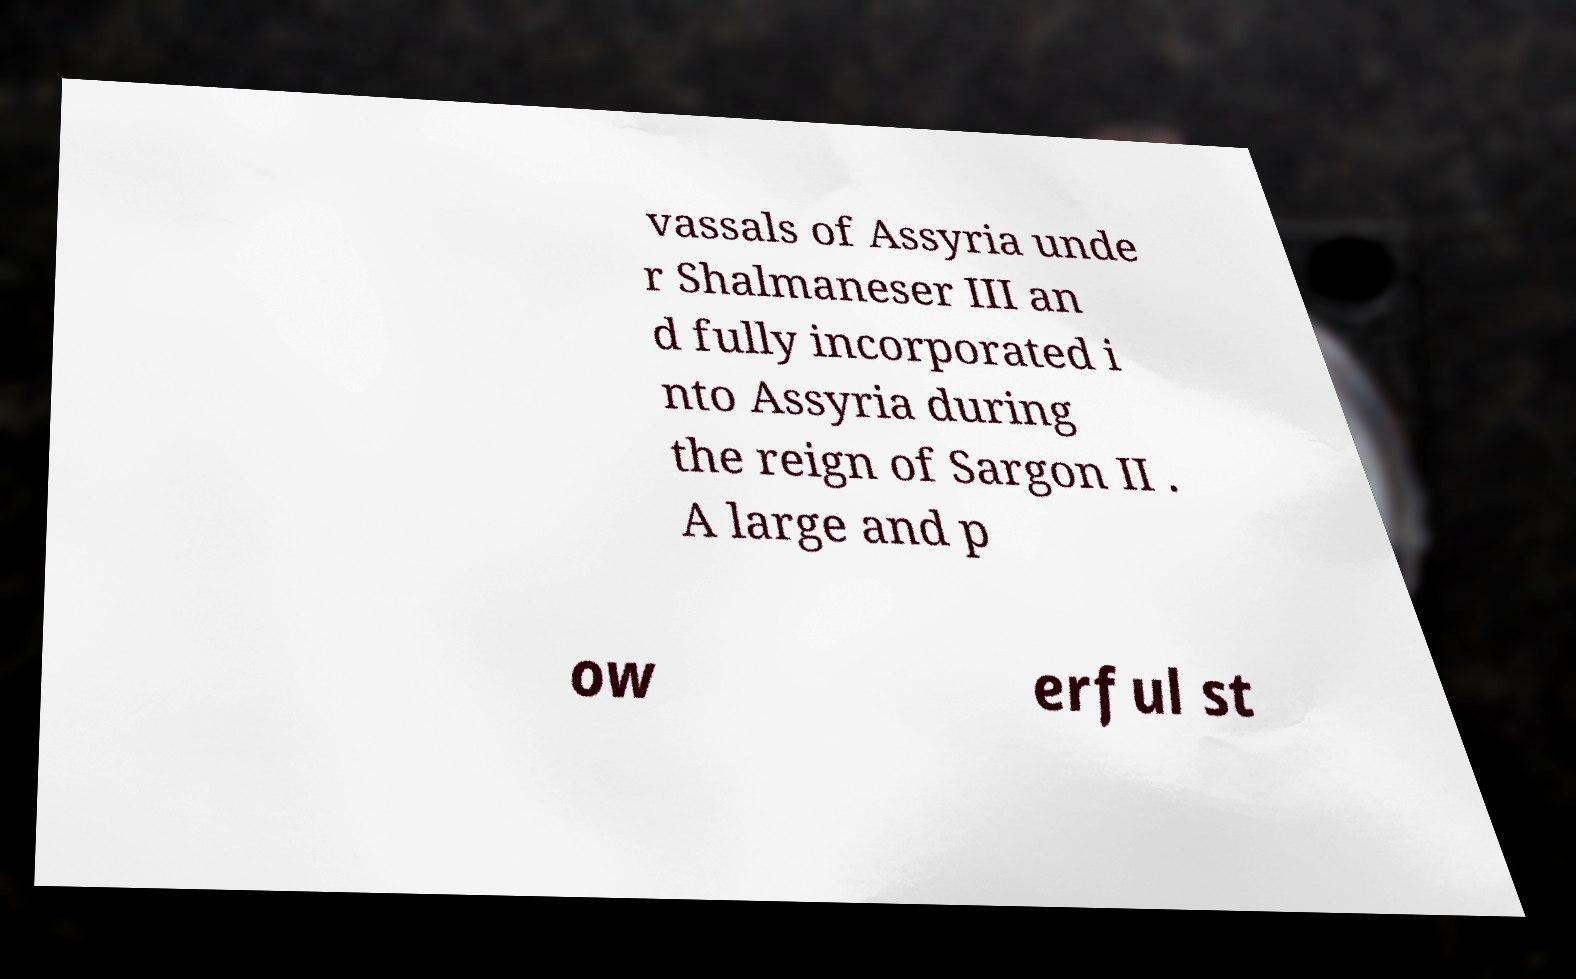Could you extract and type out the text from this image? vassals of Assyria unde r Shalmaneser III an d fully incorporated i nto Assyria during the reign of Sargon II . A large and p ow erful st 